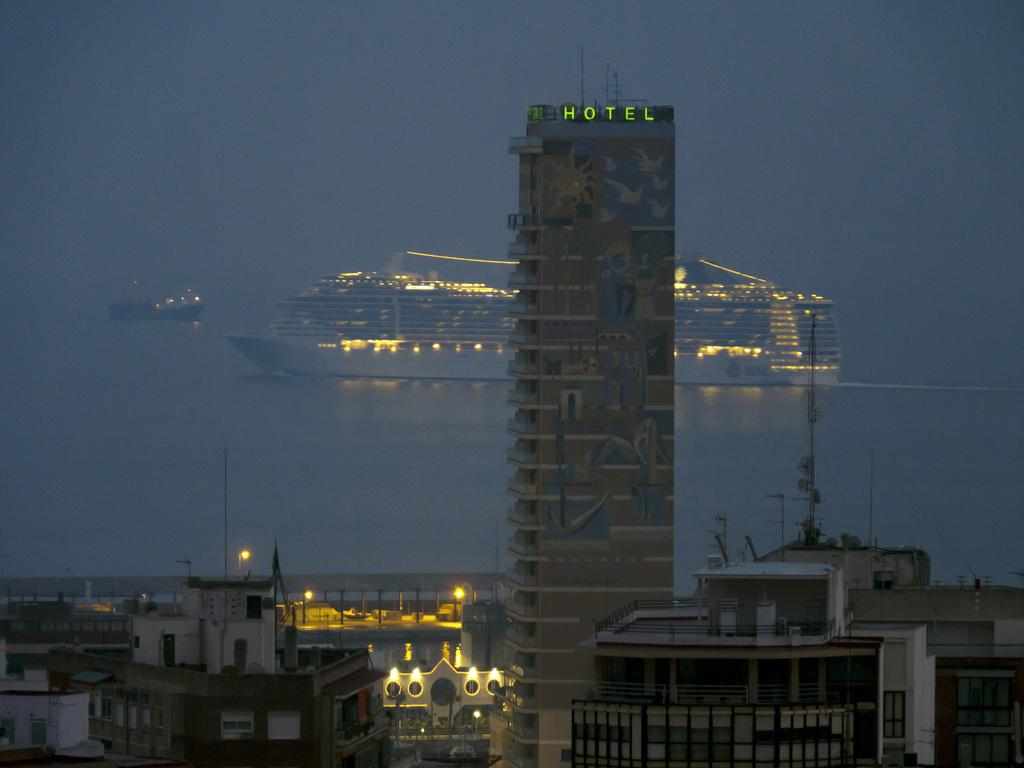What type of structures are present in the image? There are buildings in the image, including a multi-storied building. What can be seen in the backdrop of the image? There is a ship and a boat in the backdrop of the image. How would you describe the sky in the image? The sky is foggy in the image. What type of loaf is being served on the table in the image? There is no table or loaf present in the image; it features buildings, a ship, a boat, and a foggy sky. 